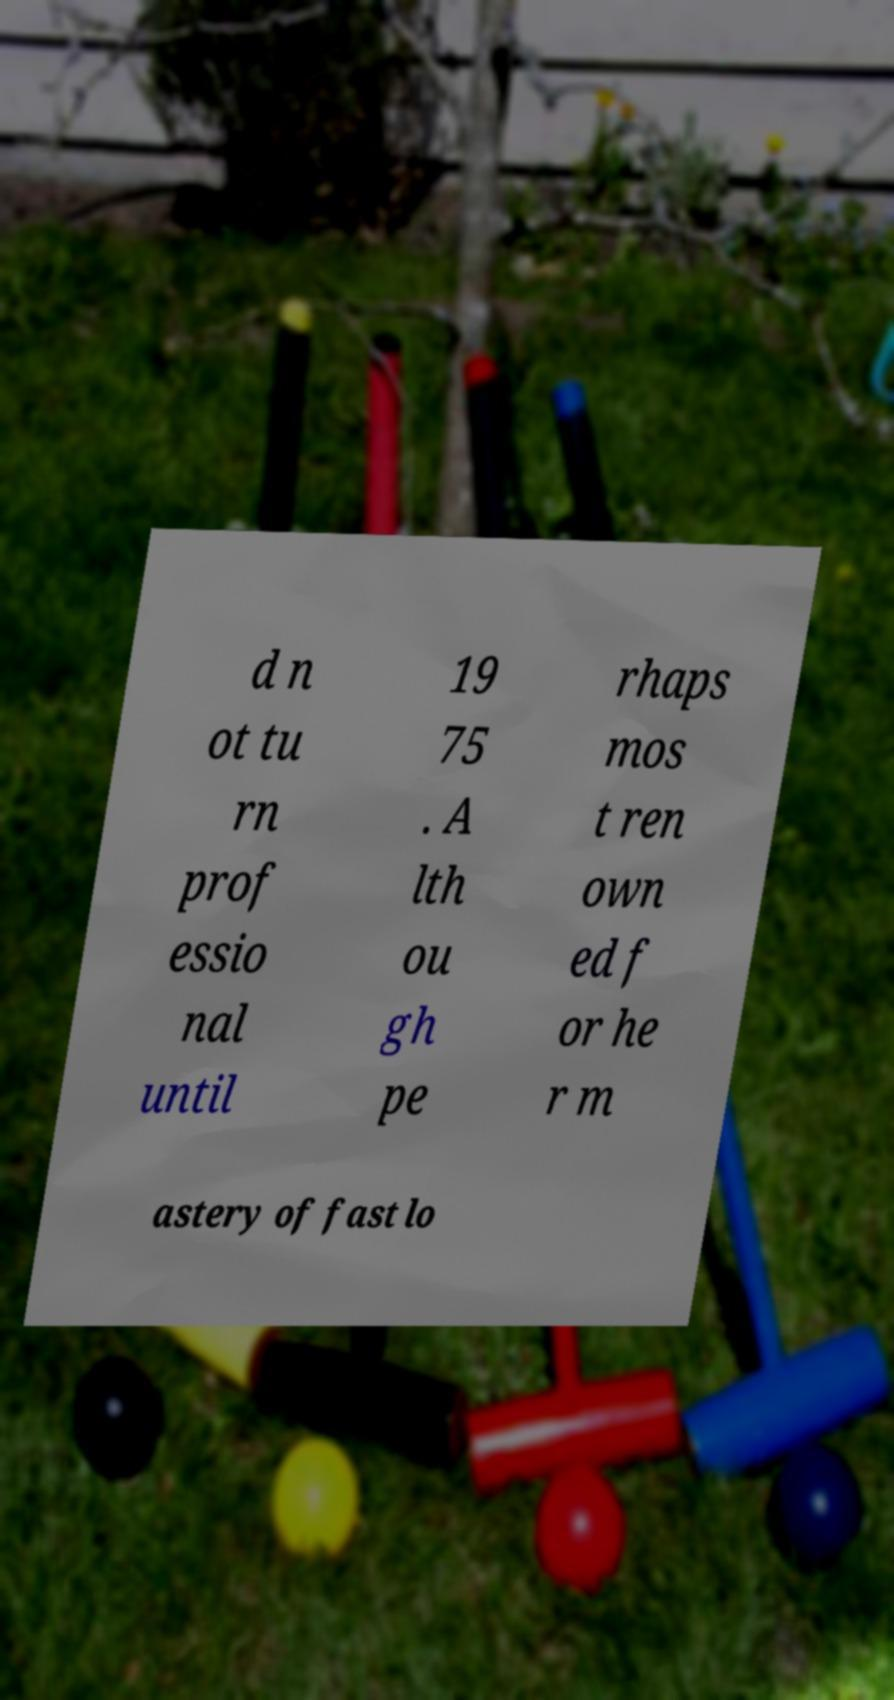Could you assist in decoding the text presented in this image and type it out clearly? d n ot tu rn prof essio nal until 19 75 . A lth ou gh pe rhaps mos t ren own ed f or he r m astery of fast lo 